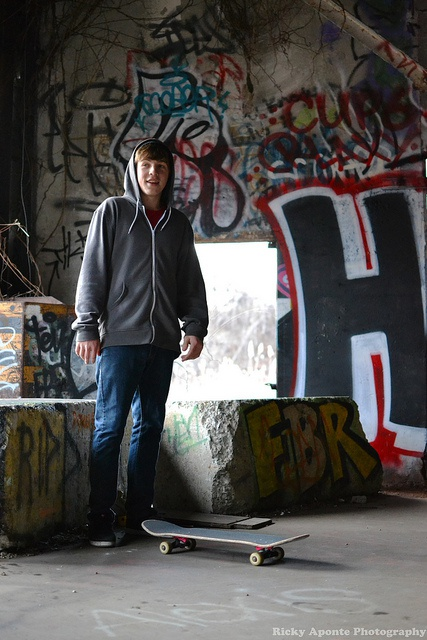Describe the objects in this image and their specific colors. I can see people in black, gray, navy, and darkgray tones and skateboard in black, gray, and darkgray tones in this image. 